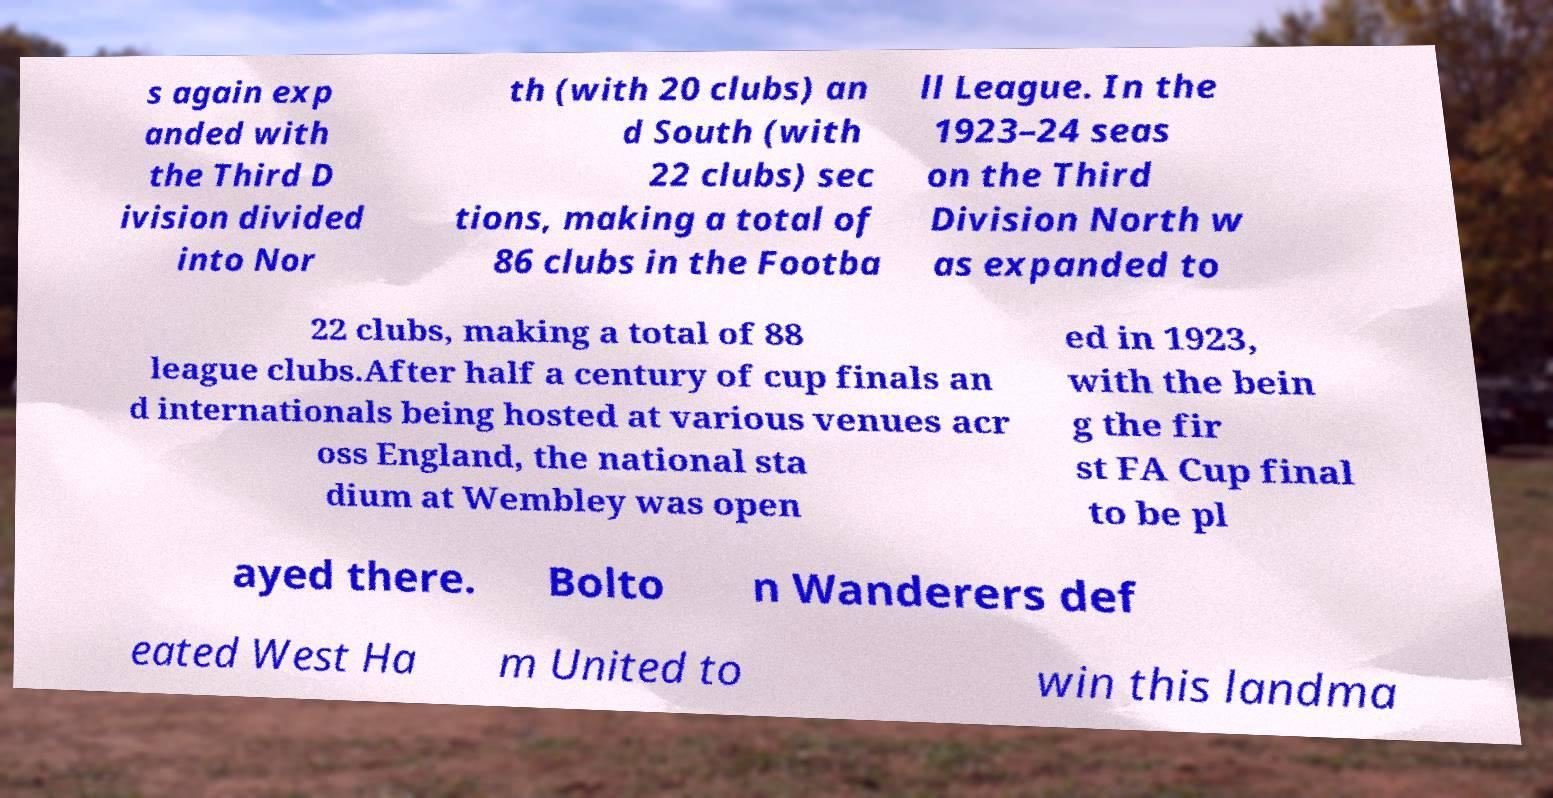Could you extract and type out the text from this image? s again exp anded with the Third D ivision divided into Nor th (with 20 clubs) an d South (with 22 clubs) sec tions, making a total of 86 clubs in the Footba ll League. In the 1923–24 seas on the Third Division North w as expanded to 22 clubs, making a total of 88 league clubs.After half a century of cup finals an d internationals being hosted at various venues acr oss England, the national sta dium at Wembley was open ed in 1923, with the bein g the fir st FA Cup final to be pl ayed there. Bolto n Wanderers def eated West Ha m United to win this landma 